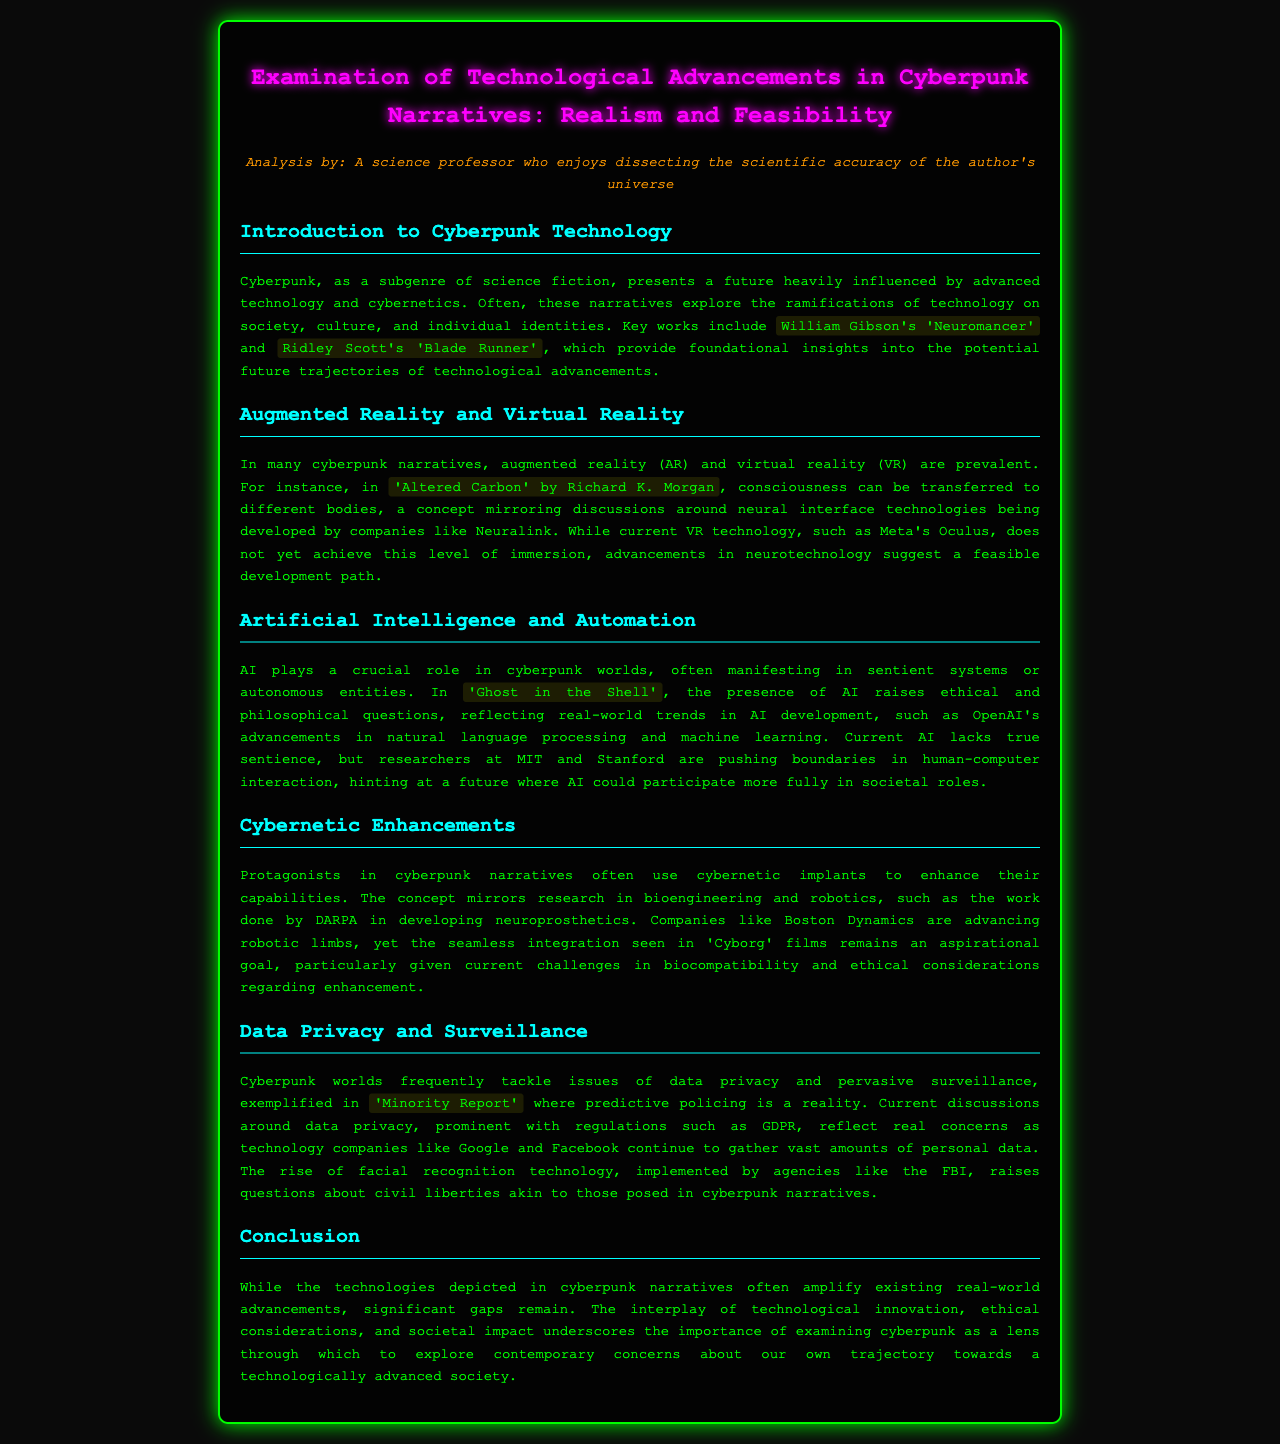What are two key works that define cyberpunk narratives? The document lists William Gibson's 'Neuromancer' and Ridley Scott's 'Blade Runner' as foundational insights into cyberpunk.
Answer: William Gibson's 'Neuromancer' and Ridley Scott's 'Blade Runner' What technology is examined alongside augmented reality and virtual reality? The document discusses the concept of consciousness transfer as seen in 'Altered Carbon,' linking it to neural interface technologies.
Answer: Neural interface technologies Which companies are mentioned in relation to bioengineering and robotics? DARPA and Boston Dynamics are referenced in the context of cybernetic enhancements and robotic advancements.
Answer: DARPA and Boston Dynamics What ethical questions does AI raise in cyberpunk narratives? The ethical and philosophical questions raised by AI are highlighted specifically in 'Ghost in the Shell'.
Answer: 'Ghost in the Shell' What societal concerns are reflected in discussions around data privacy? The document mentions GDPR and provides examples of personal data gathering by technology companies like Google and Facebook.
Answer: GDPR 